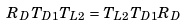<formula> <loc_0><loc_0><loc_500><loc_500>R _ { D } T _ { D 1 } T _ { L 2 } = T _ { L 2 } T _ { D 1 } R _ { D }</formula> 